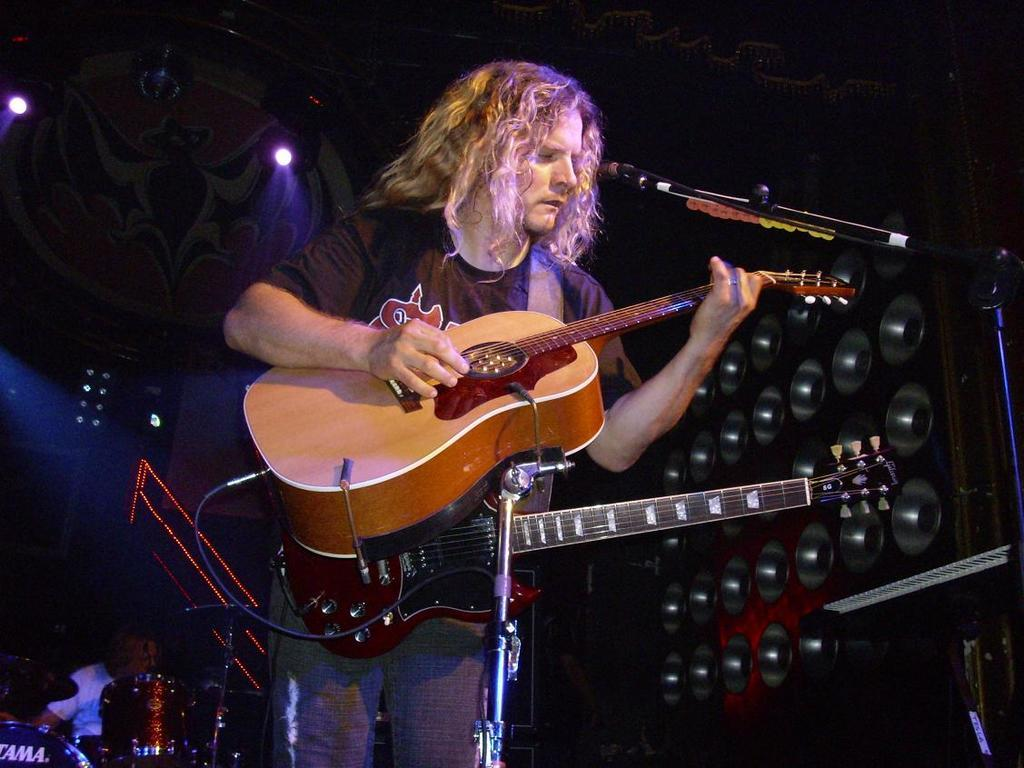Who is the main subject in the image? There is a man in the image. What is the man doing in the image? The man is standing and playing a guitar. What type of bread is the man using to play the guitar in the image? There is no bread present in the image, and the man is playing a traditional guitar, not a bread-based instrument. 